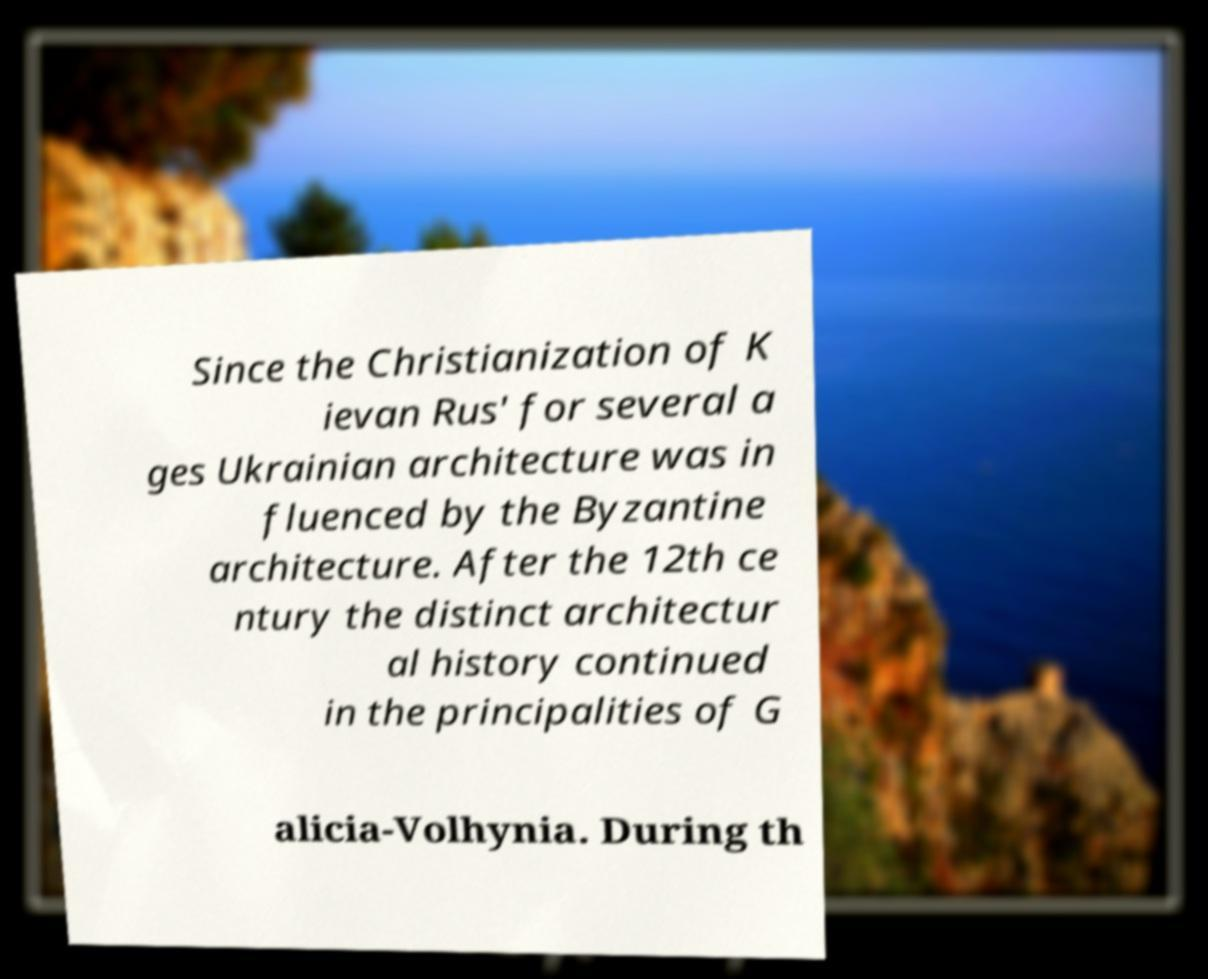Please read and relay the text visible in this image. What does it say? Since the Christianization of K ievan Rus' for several a ges Ukrainian architecture was in fluenced by the Byzantine architecture. After the 12th ce ntury the distinct architectur al history continued in the principalities of G alicia-Volhynia. During th 